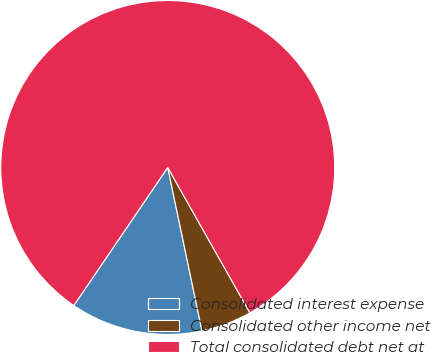Convert chart. <chart><loc_0><loc_0><loc_500><loc_500><pie_chart><fcel>Consolidated interest expense<fcel>Consolidated other income net<fcel>Total consolidated debt net at<nl><fcel>12.8%<fcel>4.9%<fcel>82.3%<nl></chart> 